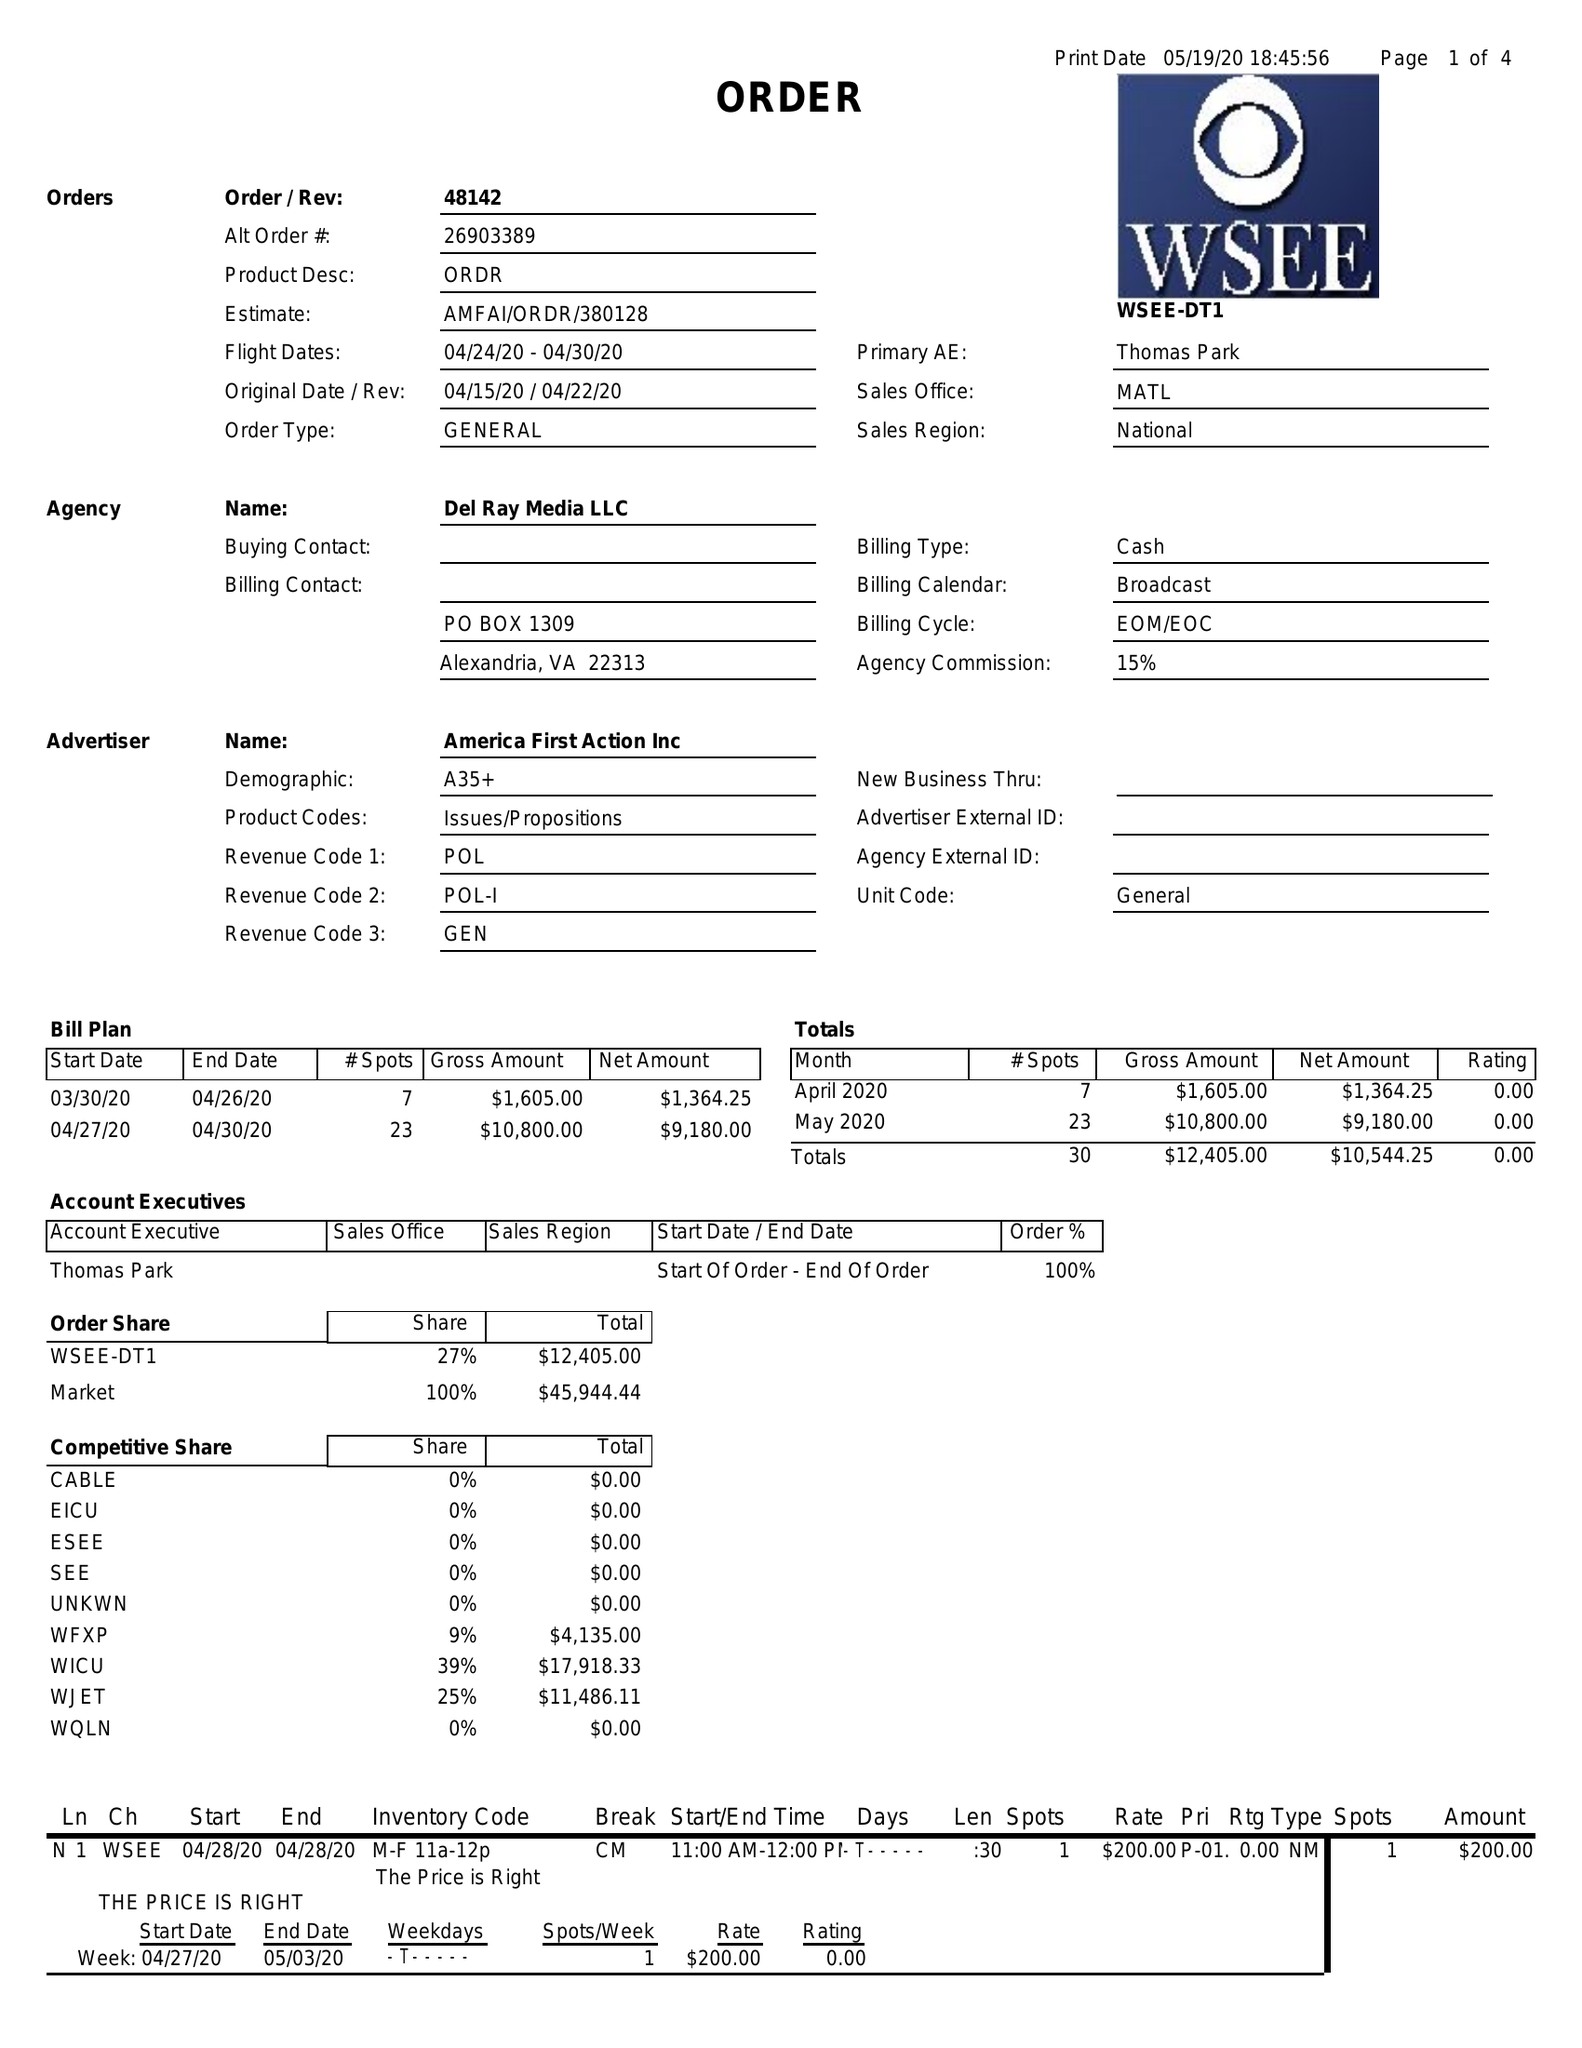What is the value for the contract_num?
Answer the question using a single word or phrase. 48142 